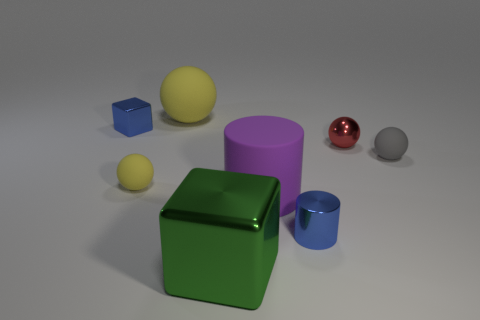Add 2 yellow rubber cylinders. How many objects exist? 10 Subtract all blocks. How many objects are left? 6 Add 4 small gray balls. How many small gray balls are left? 5 Add 4 big cylinders. How many big cylinders exist? 5 Subtract 0 yellow cylinders. How many objects are left? 8 Subtract all tiny purple matte cylinders. Subtract all yellow rubber objects. How many objects are left? 6 